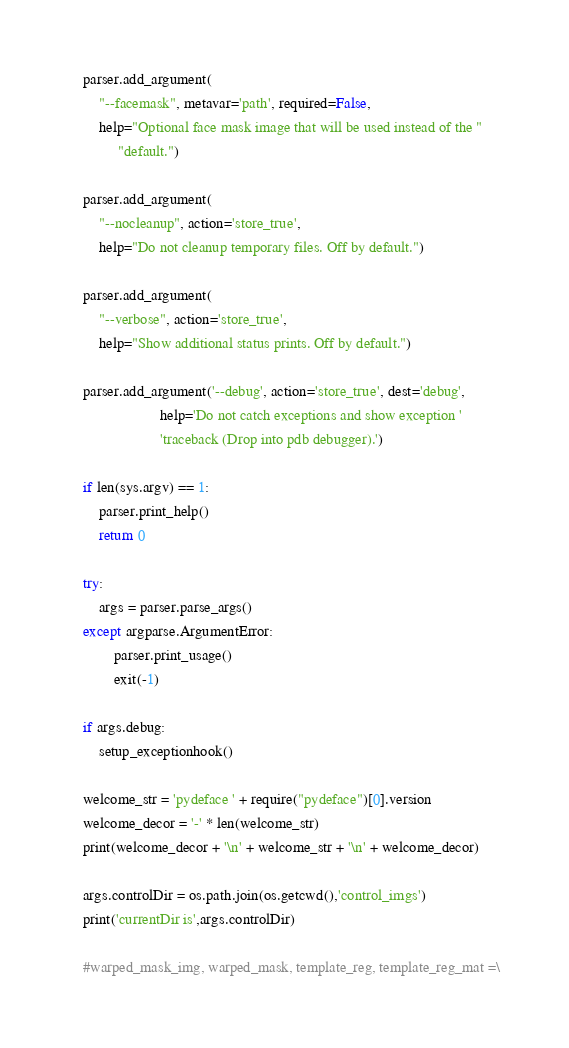<code> <loc_0><loc_0><loc_500><loc_500><_Python_>    parser.add_argument(
        "--facemask", metavar='path', required=False,
        help="Optional face mask image that will be used instead of the "
             "default.")

    parser.add_argument(
        "--nocleanup", action='store_true',
        help="Do not cleanup temporary files. Off by default.")

    parser.add_argument(
        "--verbose", action='store_true',
        help="Show additional status prints. Off by default.")

    parser.add_argument('--debug', action='store_true', dest='debug',
                        help='Do not catch exceptions and show exception '
                        'traceback (Drop into pdb debugger).')

    if len(sys.argv) == 1:
        parser.print_help()
        return 0

    try:
        args = parser.parse_args()
    except argparse.ArgumentError:
            parser.print_usage()
            exit(-1)

    if args.debug:
        setup_exceptionhook()

    welcome_str = 'pydeface ' + require("pydeface")[0].version
    welcome_decor = '-' * len(welcome_str)
    print(welcome_decor + '\n' + welcome_str + '\n' + welcome_decor)

    args.controlDir = os.path.join(os.getcwd(),'control_imgs')
    print('currentDir is',args.controlDir)

    #warped_mask_img, warped_mask, template_reg, template_reg_mat =\</code> 